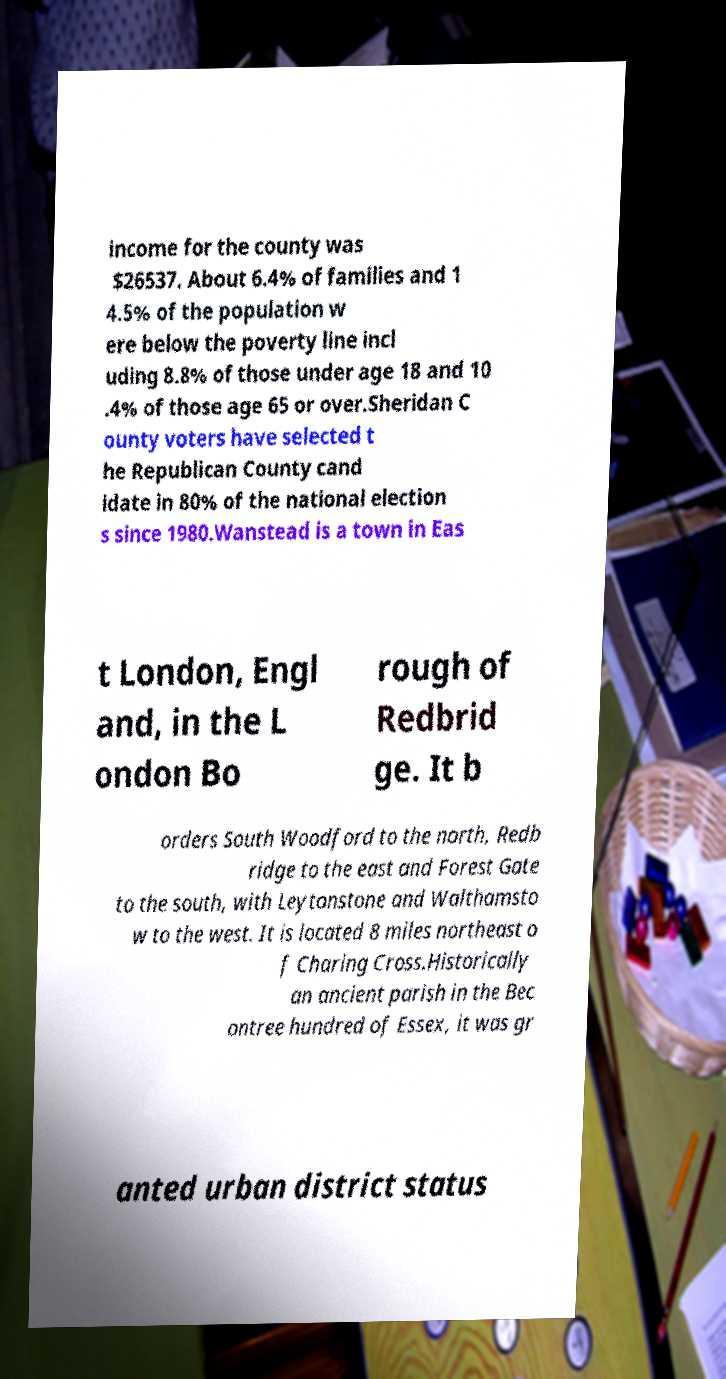Can you read and provide the text displayed in the image?This photo seems to have some interesting text. Can you extract and type it out for me? income for the county was $26537. About 6.4% of families and 1 4.5% of the population w ere below the poverty line incl uding 8.8% of those under age 18 and 10 .4% of those age 65 or over.Sheridan C ounty voters have selected t he Republican County cand idate in 80% of the national election s since 1980.Wanstead is a town in Eas t London, Engl and, in the L ondon Bo rough of Redbrid ge. It b orders South Woodford to the north, Redb ridge to the east and Forest Gate to the south, with Leytonstone and Walthamsto w to the west. It is located 8 miles northeast o f Charing Cross.Historically an ancient parish in the Bec ontree hundred of Essex, it was gr anted urban district status 